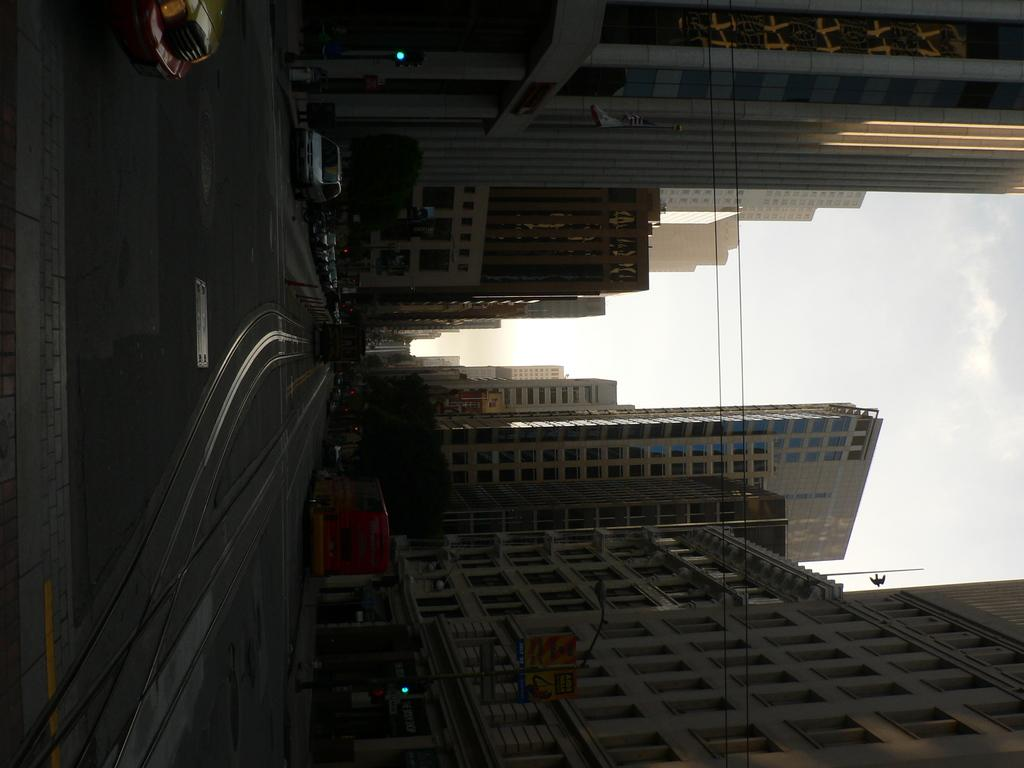What type of pathway is shown in the image? There is a road in the image. What can be seen at the top of the image? The sky is visible at the top of the image. What type of structures are present in the image? There are buildings in the image. What type of vegetation is present in the image? Trees are present in the image. What type of transportation is visible in the image? Vehicles are visible in the image. Can you tell me how many tins are floating in the ocean in the image? There is no ocean or tin present in the image. What type of day is depicted in the image? The provided facts do not mention the time of day or weather conditions, so it cannot be determined from the image. 